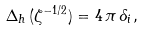Convert formula to latex. <formula><loc_0><loc_0><loc_500><loc_500>\Delta _ { h } \, ( \zeta ^ { - 1 / 2 } ) = 4 \, \pi \, \delta _ { i } ,</formula> 